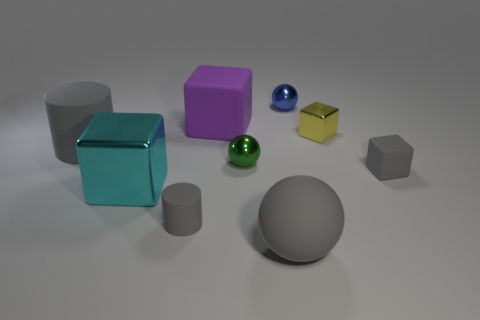Is the number of metal things less than the number of gray cylinders?
Give a very brief answer. No. What is the object that is behind the yellow metallic thing and to the right of the small green metal sphere made of?
Offer a terse response. Metal. What size is the sphere behind the big purple rubber object that is behind the matte cube in front of the large gray matte cylinder?
Give a very brief answer. Small. There is a big cyan shiny object; does it have the same shape as the big matte object in front of the big cyan block?
Provide a short and direct response. No. How many things are both to the right of the tiny gray cylinder and to the left of the tiny gray block?
Give a very brief answer. 5. How many brown things are big cubes or metallic cubes?
Offer a very short reply. 0. There is a matte block that is right of the purple cube; is it the same color as the small ball in front of the tiny blue shiny thing?
Keep it short and to the point. No. The large cube right of the gray cylinder that is in front of the large gray matte object behind the big rubber ball is what color?
Provide a succinct answer. Purple. There is a large matte thing that is left of the purple rubber block; are there any gray matte cubes on the left side of it?
Your response must be concise. No. There is a matte object that is right of the tiny metal cube; does it have the same shape as the green thing?
Provide a short and direct response. No. 